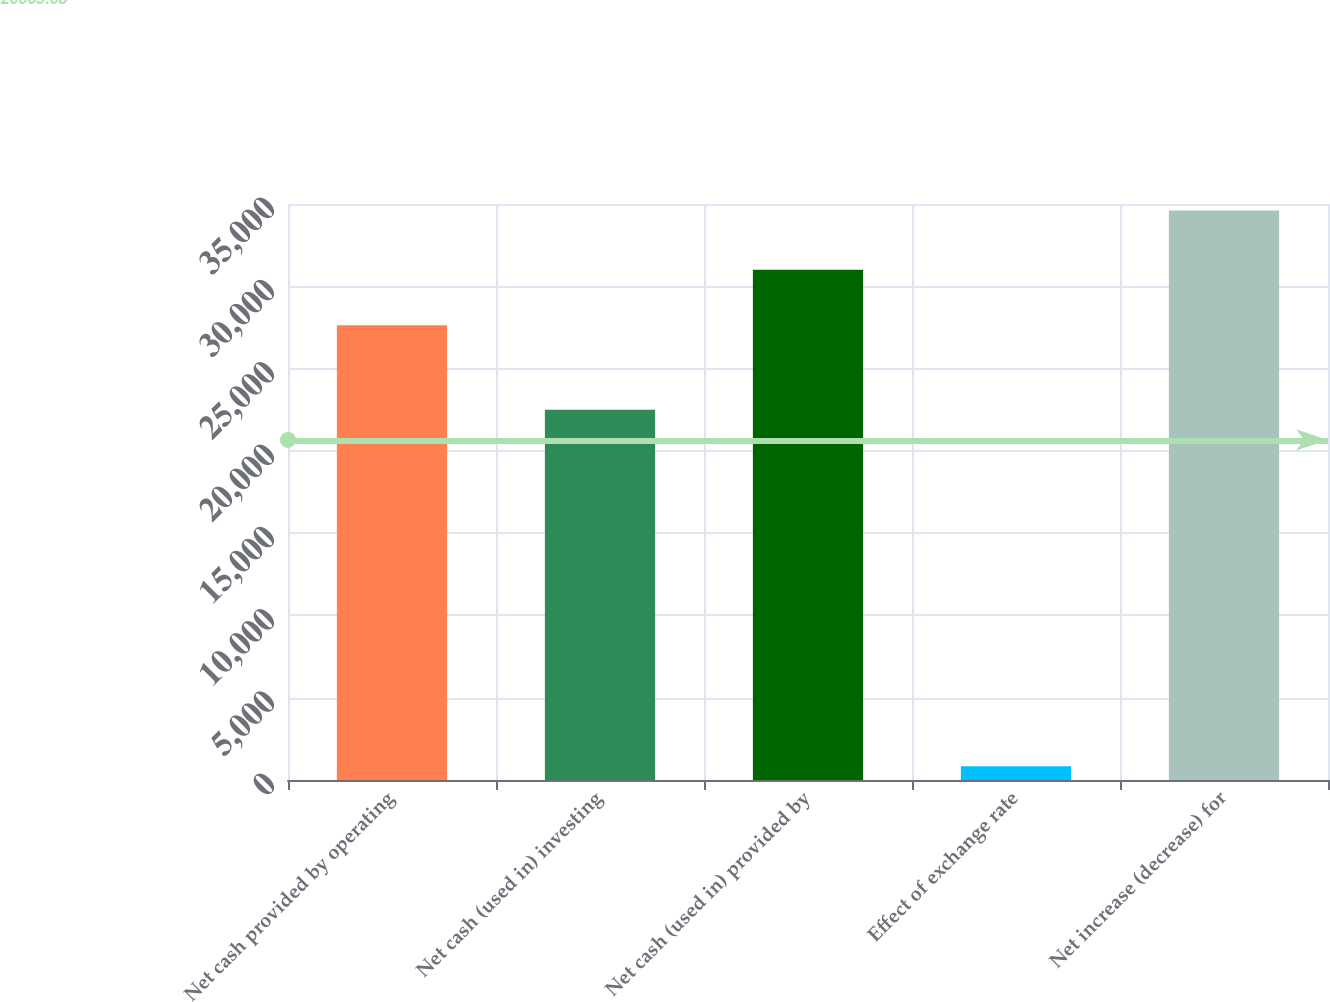Convert chart to OTSL. <chart><loc_0><loc_0><loc_500><loc_500><bar_chart><fcel>Net cash provided by operating<fcel>Net cash (used in) investing<fcel>Net cash (used in) provided by<fcel>Effect of exchange rate<fcel>Net increase (decrease) for<nl><fcel>27634<fcel>22499<fcel>31011.8<fcel>834<fcel>34612<nl></chart> 